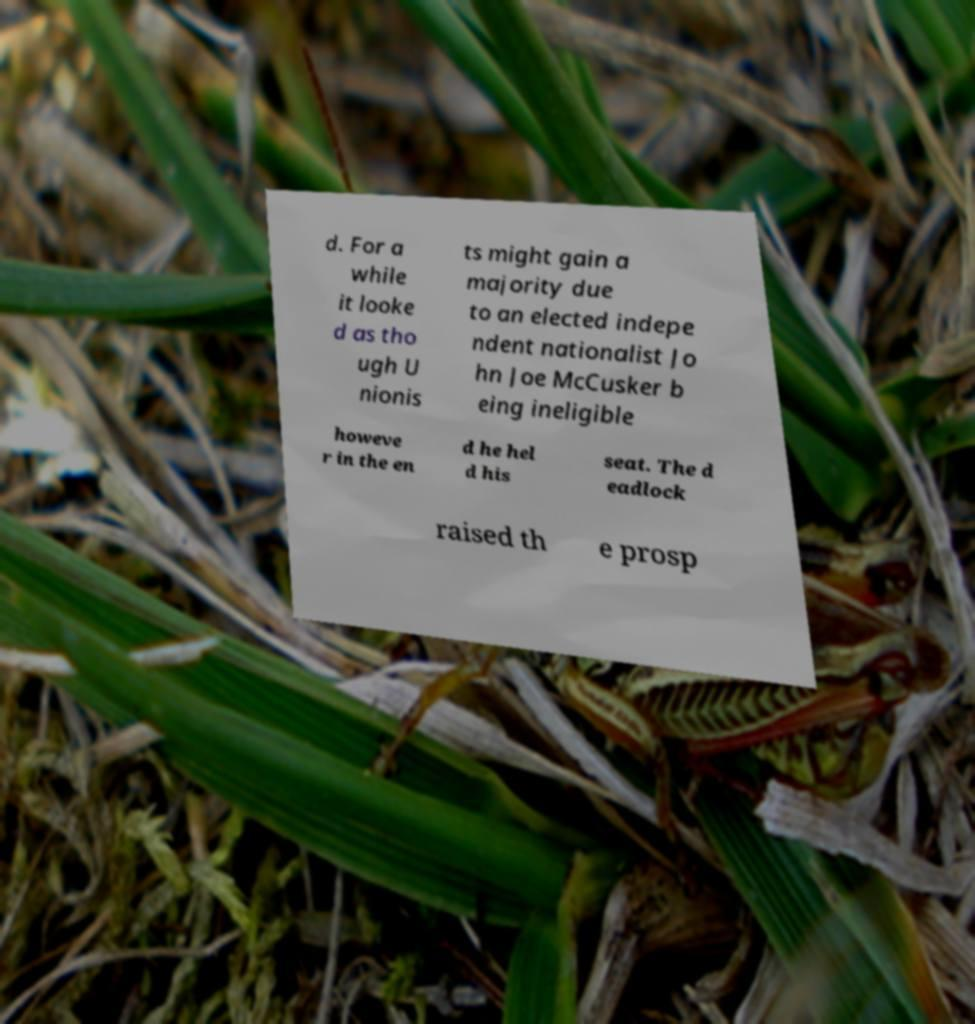What messages or text are displayed in this image? I need them in a readable, typed format. d. For a while it looke d as tho ugh U nionis ts might gain a majority due to an elected indepe ndent nationalist Jo hn Joe McCusker b eing ineligible howeve r in the en d he hel d his seat. The d eadlock raised th e prosp 